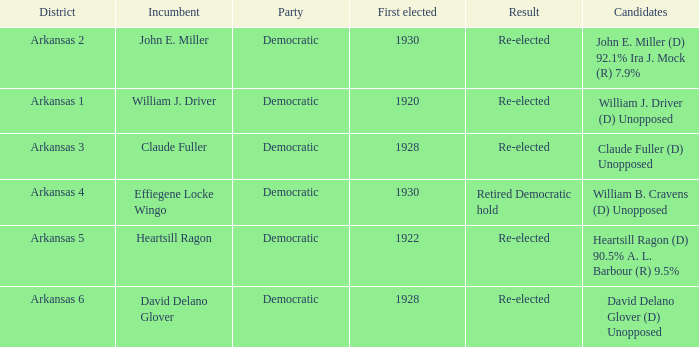In what district was John E. Miller the incumbent?  Arkansas 2. 